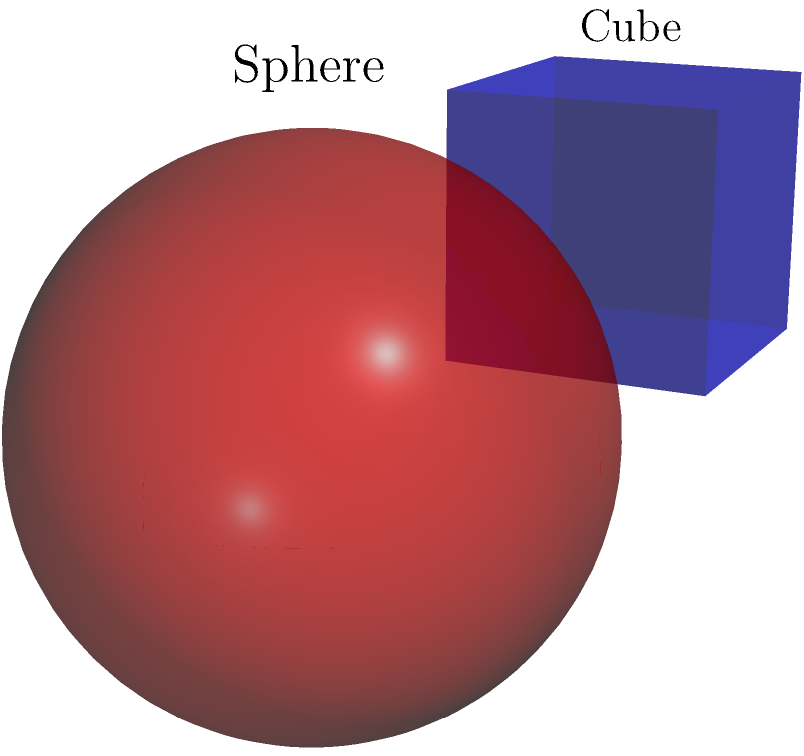Compare the volumes of a cube with side length 2 units, a sphere with radius 1 unit, and a cylinder with radius 1 unit and height 2 units. Which shape has the largest volume? Let's calculate the volume of each shape:

1. Cube:
   Volume = side length³
   $V_{cube} = 2³ = 8$ cubic units

2. Sphere:
   Volume = $\frac{4}{3}\pi r³$
   $V_{sphere} = \frac{4}{3}\pi(1³) = \frac{4}{3}\pi \approx 4.19$ cubic units

3. Cylinder:
   Volume = $\pi r²h$
   $V_{cylinder} = \pi(1²)(2) = 2\pi \approx 6.28$ cubic units

Comparing the volumes:
$V_{cube} = 8 > V_{cylinder} \approx 6.28 > V_{sphere} \approx 4.19$

Therefore, the cube has the largest volume among the three shapes.
Answer: The cube has the largest volume. 